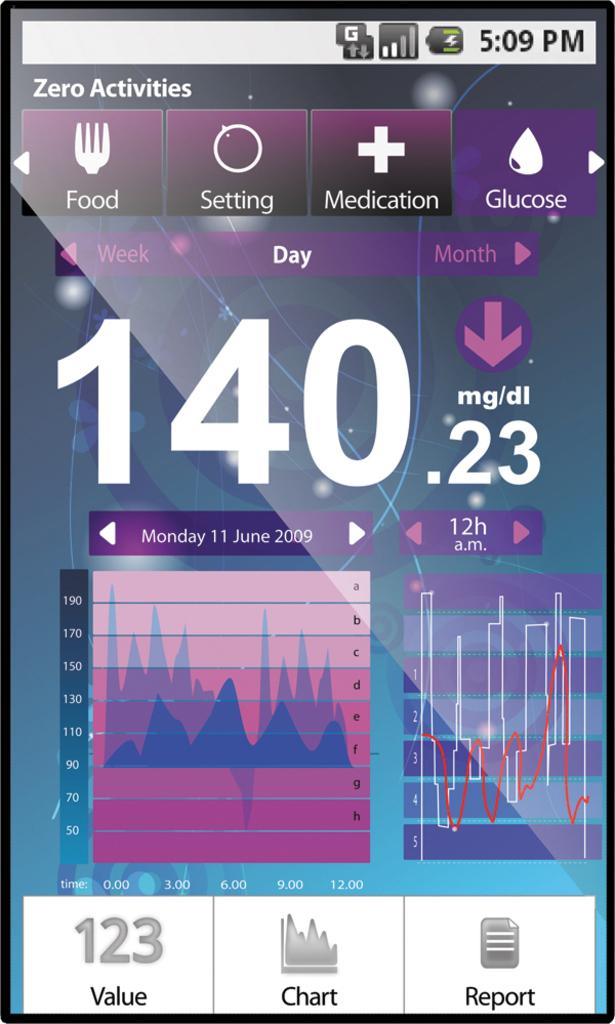<image>
Describe the image concisely. An app on a phone displays the glucose level of someone as 140.23 mg/dl. 